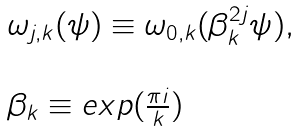Convert formula to latex. <formula><loc_0><loc_0><loc_500><loc_500>\begin{array} { l } \omega _ { j , k } ( \psi ) \equiv \omega _ { 0 , k } ( \beta _ { k } ^ { 2 j } \psi ) , \\ \\ \beta _ { k } \equiv e x p ( \frac { \pi i } { k } ) \end{array}</formula> 